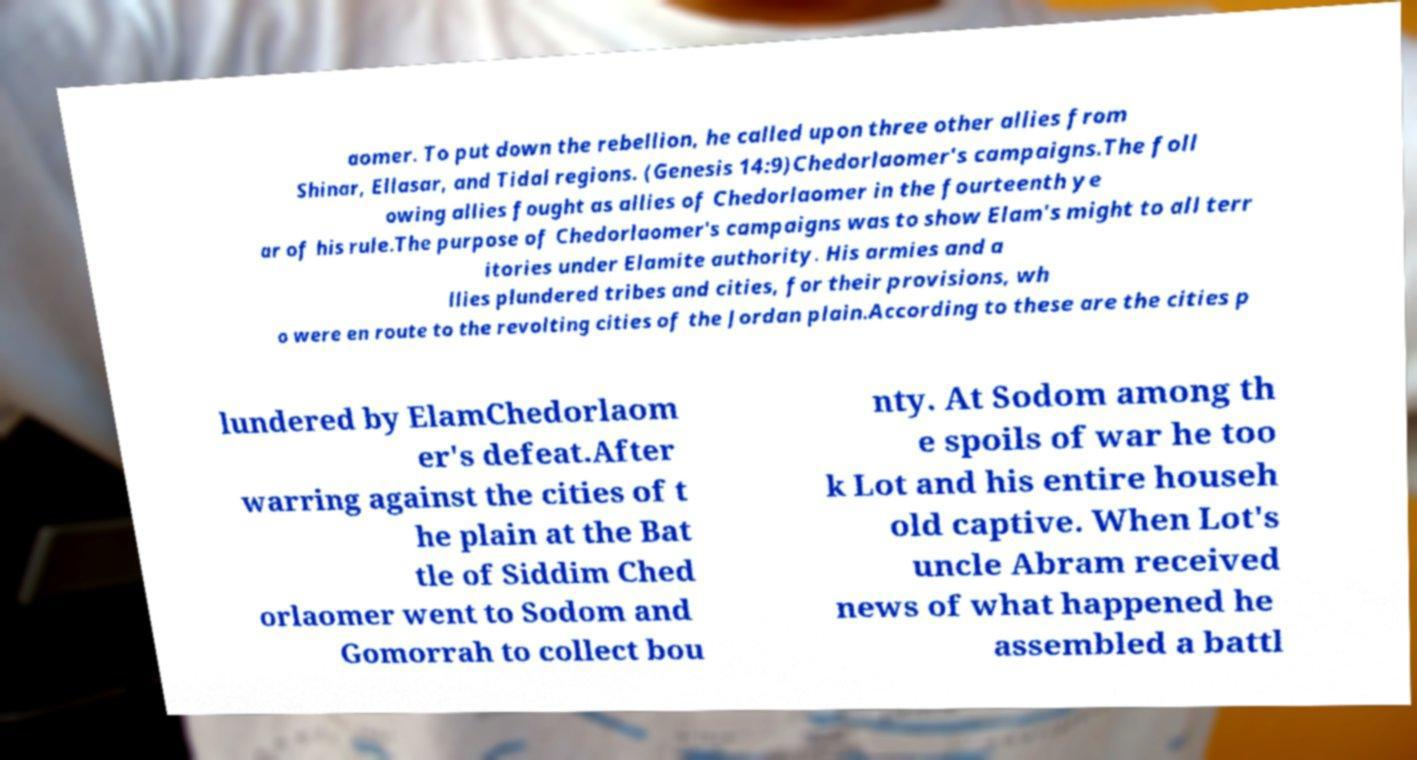What messages or text are displayed in this image? I need them in a readable, typed format. aomer. To put down the rebellion, he called upon three other allies from Shinar, Ellasar, and Tidal regions. (Genesis 14:9)Chedorlaomer's campaigns.The foll owing allies fought as allies of Chedorlaomer in the fourteenth ye ar of his rule.The purpose of Chedorlaomer's campaigns was to show Elam's might to all terr itories under Elamite authority. His armies and a llies plundered tribes and cities, for their provisions, wh o were en route to the revolting cities of the Jordan plain.According to these are the cities p lundered by ElamChedorlaom er's defeat.After warring against the cities of t he plain at the Bat tle of Siddim Ched orlaomer went to Sodom and Gomorrah to collect bou nty. At Sodom among th e spoils of war he too k Lot and his entire househ old captive. When Lot's uncle Abram received news of what happened he assembled a battl 